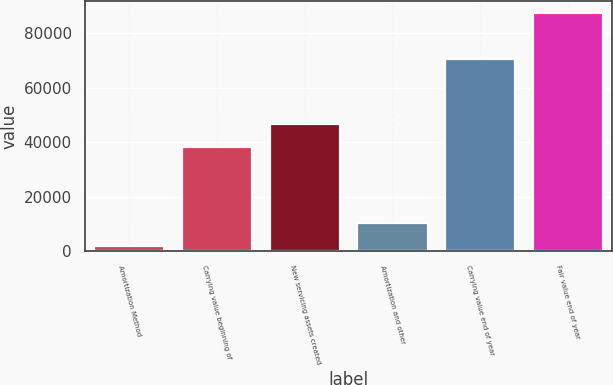Convert chart. <chart><loc_0><loc_0><loc_500><loc_500><bar_chart><fcel>Amortization Method<fcel>Carrying value beginning of<fcel>New servicing assets created<fcel>Amortization and other<fcel>Carrying value end of year<fcel>Fair value end of year<nl><fcel>2010<fcel>38165<fcel>46710.1<fcel>10555.1<fcel>70516<fcel>87461<nl></chart> 